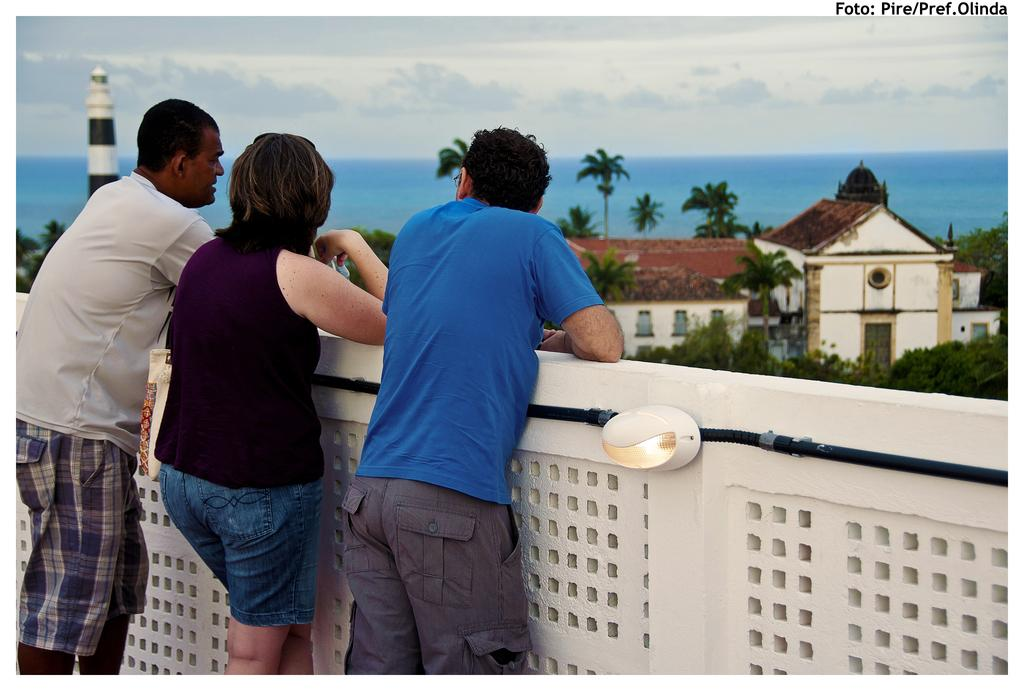What is one of the main structures visible in the image? There is a wall in the image. What can be seen attached to the wall? There is a light in the image. What type of object is present near the wall? There is a pipe in the image. How many people are standing in the image? There are three people standing in the image. What is visible in the background of the image? Trees, buildings, a tower, water, and the sky are visible in the background of the image. What type of pollution can be seen in the image? There is no pollution visible in the image. What type of frame surrounds the image? The image does not have a frame; it is a photograph or digital image without a physical frame. 